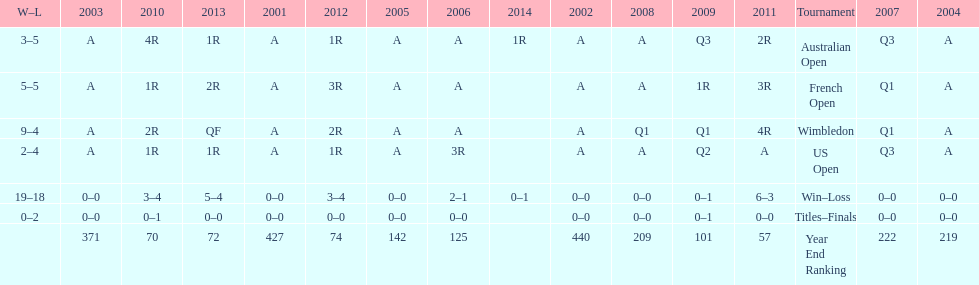In which years were there only 1 loss? 2006, 2009, 2014. 